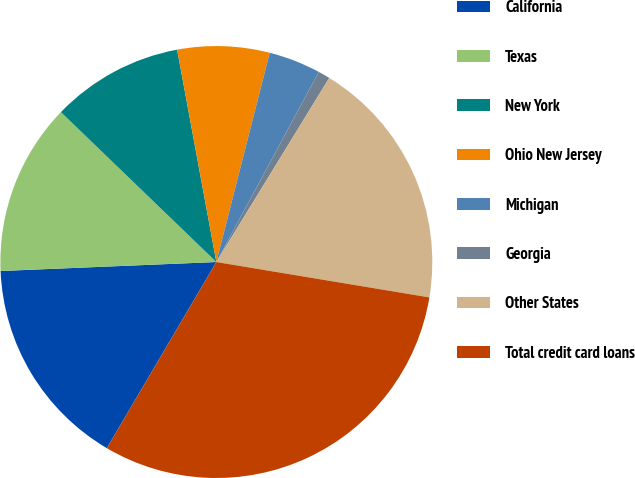<chart> <loc_0><loc_0><loc_500><loc_500><pie_chart><fcel>California<fcel>Texas<fcel>New York<fcel>Ohio New Jersey<fcel>Michigan<fcel>Georgia<fcel>Other States<fcel>Total credit card loans<nl><fcel>15.87%<fcel>12.87%<fcel>9.88%<fcel>6.88%<fcel>3.89%<fcel>0.89%<fcel>18.86%<fcel>30.84%<nl></chart> 